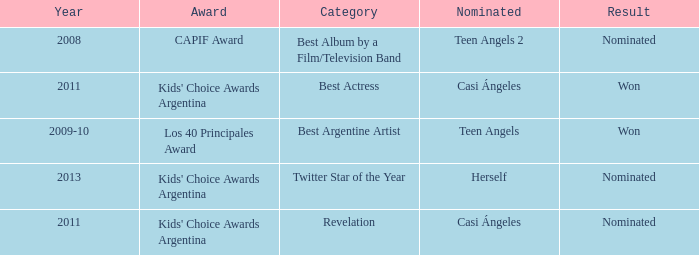What year saw an award in the category of Revelation? 2011.0. 